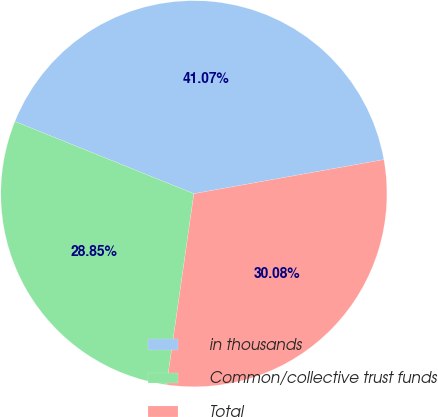Convert chart to OTSL. <chart><loc_0><loc_0><loc_500><loc_500><pie_chart><fcel>in thousands<fcel>Common/collective trust funds<fcel>Total<nl><fcel>41.07%<fcel>28.85%<fcel>30.08%<nl></chart> 